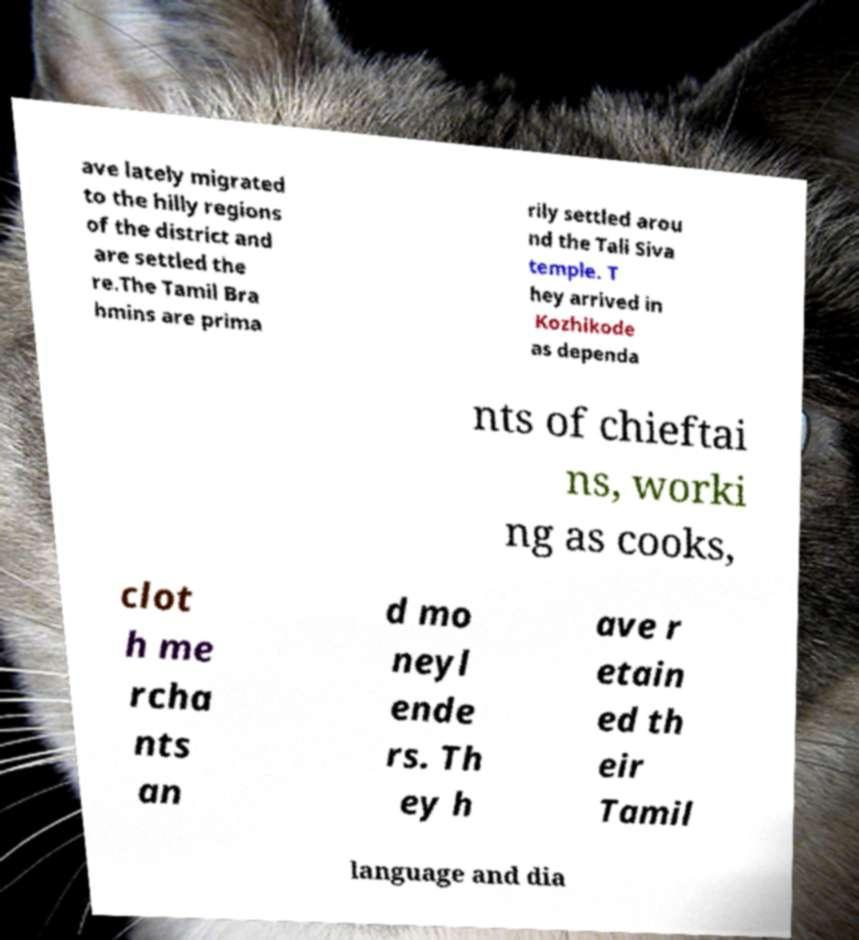What messages or text are displayed in this image? I need them in a readable, typed format. ave lately migrated to the hilly regions of the district and are settled the re.The Tamil Bra hmins are prima rily settled arou nd the Tali Siva temple. T hey arrived in Kozhikode as dependa nts of chieftai ns, worki ng as cooks, clot h me rcha nts an d mo neyl ende rs. Th ey h ave r etain ed th eir Tamil language and dia 